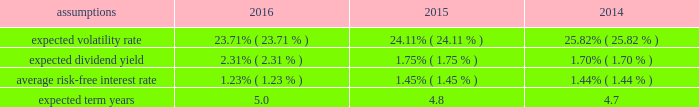Notes to the audited consolidated financial statements director stock compensation subplan eastman's 2016 director stock compensation subplan ( "directors' subplan" ) , a component of the 2012 omnibus plan , remains in effect until terminated by the board of directors or the earlier termination of thf e 2012 omnibus plan .
The directors' subplan provides for structured awards of restricted shares to non-employee members of the board of directors .
Restricted shares awarded under the directors' subplan are subject to the same terms and conditions of the 2012 omnibus plan .
The directors' subplan does not constitute a separate source of shares for grant of equity awards and all shares awarded are part of the 10 million shares authorized under the 2012 omnibus plan .
Shares of restricted stock are granted on the first day of a non-f employee director's initial term of service and shares of restricted stock are granted each year to each non-employee director on the date of the annual meeting of stockholders .
General the company is authorized by the board of directors under the 2012 omnibus plan tof provide awards to employees and non- employee members of the board of directors .
It has been the company's practice to issue new shares rather than treasury shares for equity awards that require settlement by the issuance of common stock and to withhold or accept back shares awarded to cover the related income tax obligations of employee participants .
Shares of unrestricted common stock owned by non-d employee directors are not eligible to be withheld or acquired to satisfy the withholding obligation related to their income taxes .
Aa shares of unrestricted common stock owned by specified senior management level employees are accepted by the company to pay the exercise price of stock options in accordance with the terms and conditions of their awards .
For 2016 , 2015 , and 2014 , total share-based compensation expense ( before tax ) of approximately $ 36 million , $ 36 million , and $ 28 million , respectively , was recognized in selling , general and administrative exd pense in the consolidated statements of earnings , comprehensive income and retained earnings for all share-based awards of which approximately $ 7 million , $ 7 million , and $ 4 million , respectively , related to stock options .
The compensation expense is recognized over the substantive vesting period , which may be a shorter time period than the stated vesting period for qualifying termination eligible employees as defined in the forms of award notice .
For 2016 , 2015 , and 2014 , approximately $ 2 million , $ 2 million , and $ 1 million , respectively , of stock option compensation expense was recognized due to qualifying termination eligibility preceding the requisite vesting period .
Stock option awards options have been granted on an annual basis to non-employee directors under the directors' subplan and predecessor plans and by the compensation and management development committee of the board of directors under the 2012 omnibus plan and predecessor plans to employees .
Option awards have an exercise price equal to the closing price of the company's stock on the date of grant .
The term of options is 10 years with vesting periods thf at vary up to three years .
Vesting usually occurs ratably over the vesting period or at the end of the vesting period .
The company utilizes the black scholes merton option valuation model which relies on certain assumptions to estimate an option's fair value .
The weighted average assumptions used in the determination of fair value for stock options awarded in 2016 , 2015 , and 2014 are provided in the table below: .

What was the cumulative stock option compensation expense was recognized due to qualifying termination eligibility preceding the requisite vesting period from 2014 to 2016 in millions? 
Computations: ((2 + 2) + 1)
Answer: 5.0. 